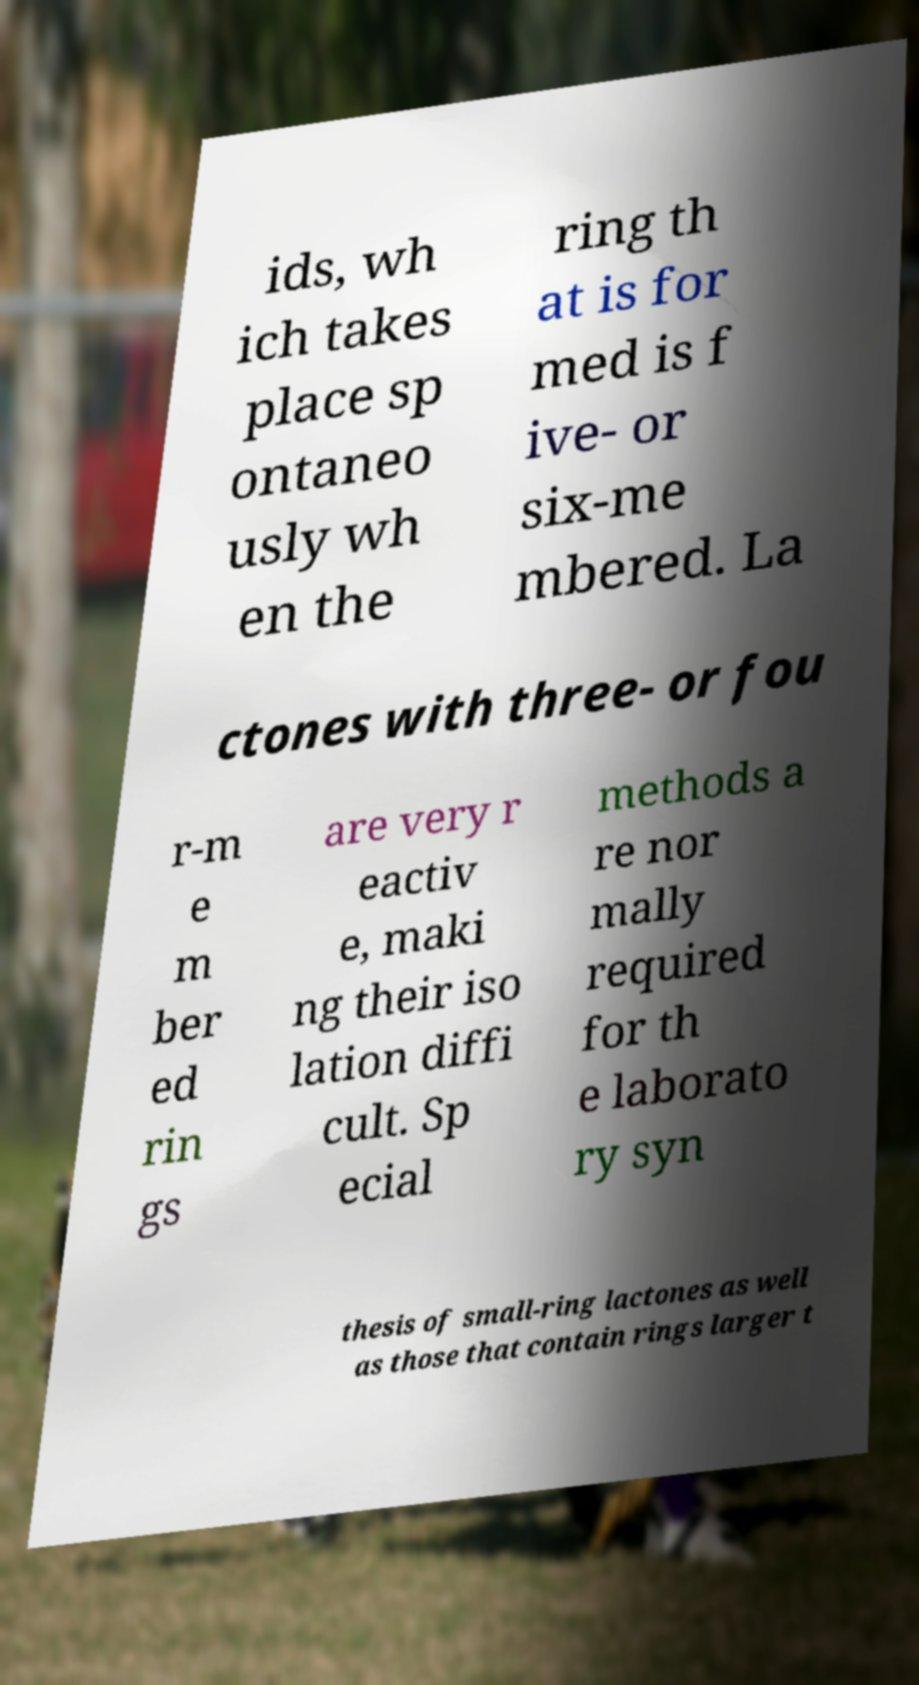What messages or text are displayed in this image? I need them in a readable, typed format. ids, wh ich takes place sp ontaneo usly wh en the ring th at is for med is f ive- or six-me mbered. La ctones with three- or fou r-m e m ber ed rin gs are very r eactiv e, maki ng their iso lation diffi cult. Sp ecial methods a re nor mally required for th e laborato ry syn thesis of small-ring lactones as well as those that contain rings larger t 